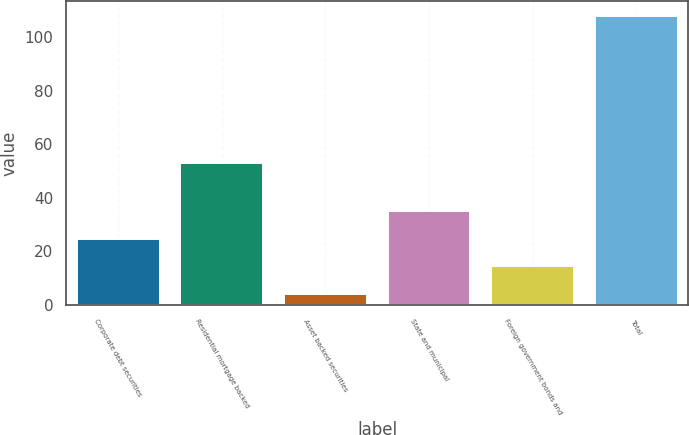<chart> <loc_0><loc_0><loc_500><loc_500><bar_chart><fcel>Corporate debt securities<fcel>Residential mortgage backed<fcel>Asset backed securities<fcel>State and municipal<fcel>Foreign government bonds and<fcel>Total<nl><fcel>24.8<fcel>53<fcel>4<fcel>35.2<fcel>14.4<fcel>108<nl></chart> 